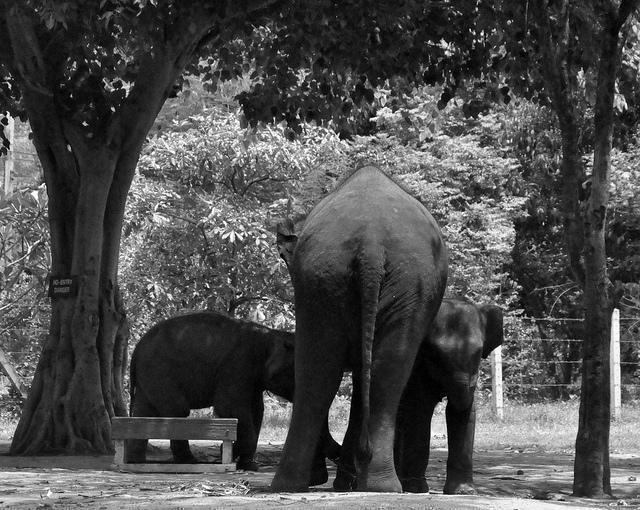How many elephants are in the picture?
Give a very brief answer. 3. How many elephants are visible?
Give a very brief answer. 3. How many vases are in the picture?
Give a very brief answer. 0. 